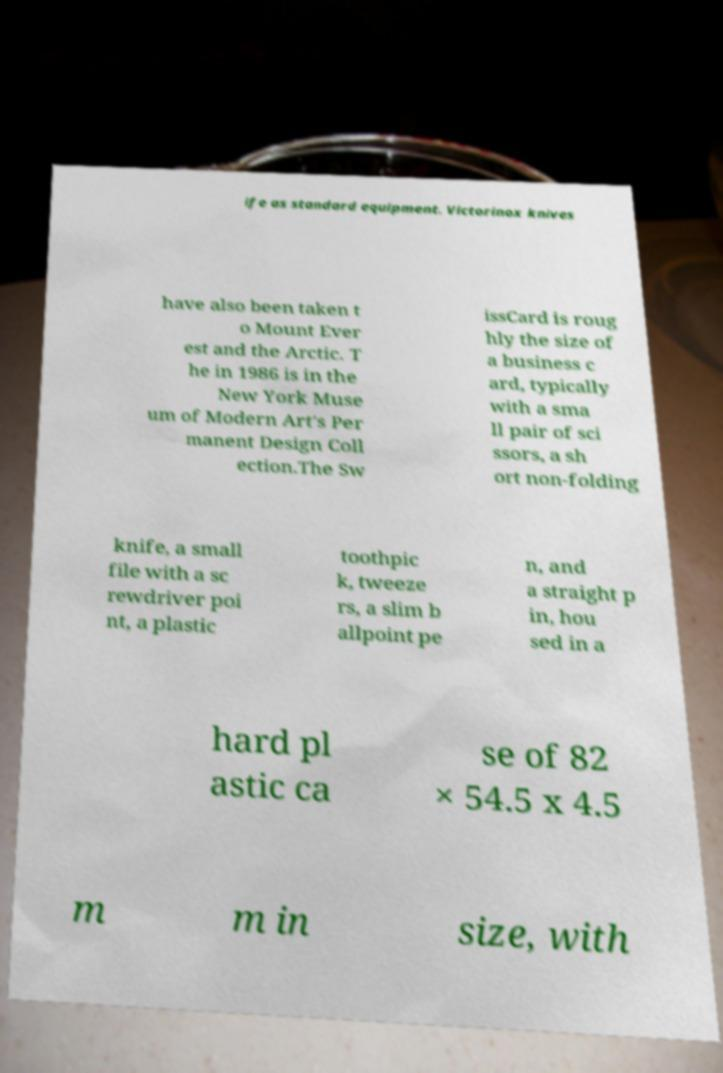Can you read and provide the text displayed in the image?This photo seems to have some interesting text. Can you extract and type it out for me? ife as standard equipment. Victorinox knives have also been taken t o Mount Ever est and the Arctic. T he in 1986 is in the New York Muse um of Modern Art's Per manent Design Coll ection.The Sw issCard is roug hly the size of a business c ard, typically with a sma ll pair of sci ssors, a sh ort non-folding knife, a small file with a sc rewdriver poi nt, a plastic toothpic k, tweeze rs, a slim b allpoint pe n, and a straight p in, hou sed in a hard pl astic ca se of 82 × 54.5 x 4.5 m m in size, with 